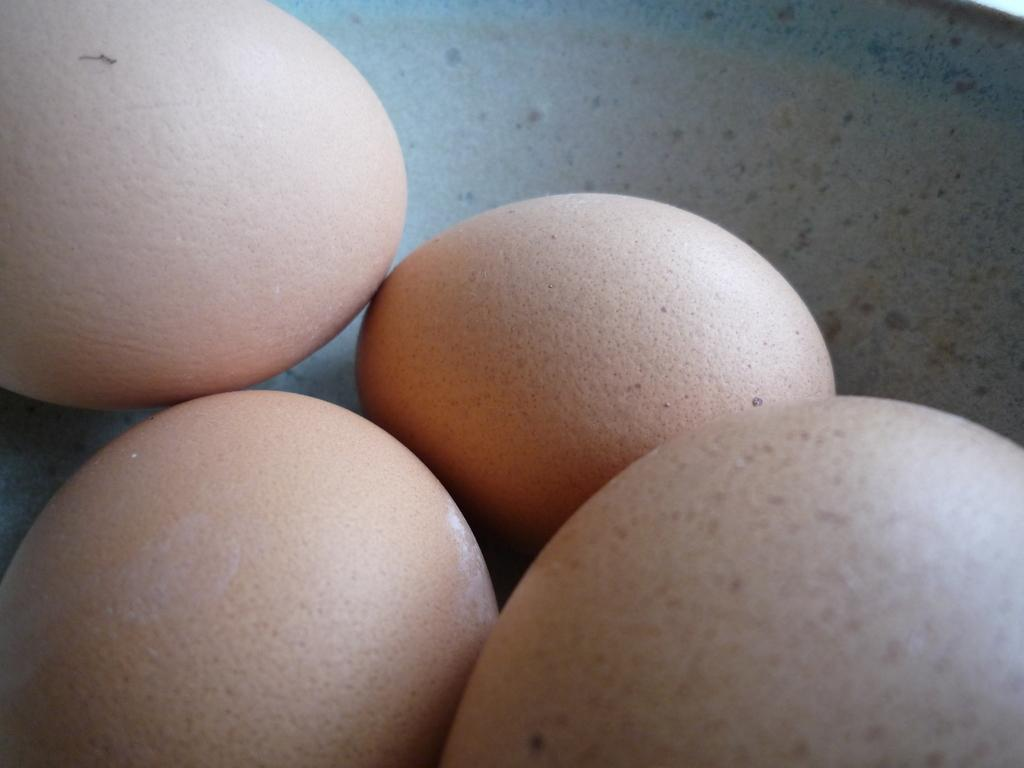How many eggs are visible in the image? There are four eggs in the image. What is the color of the background in the image? The background is white in color. What might be the object containing the eggs? The object containing the eggs might be a plate or a bowl. What type of cough can be heard in the image? There is no sound or indication of a cough in the image. 